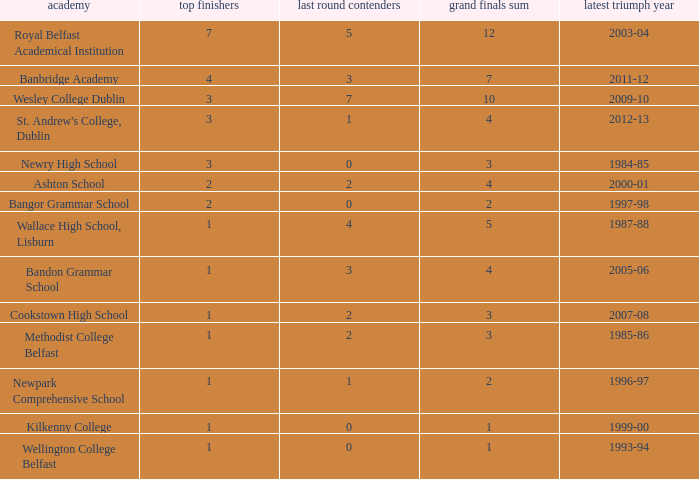What are the names that had a finalist score of 2? Ashton School, Cookstown High School, Methodist College Belfast. 